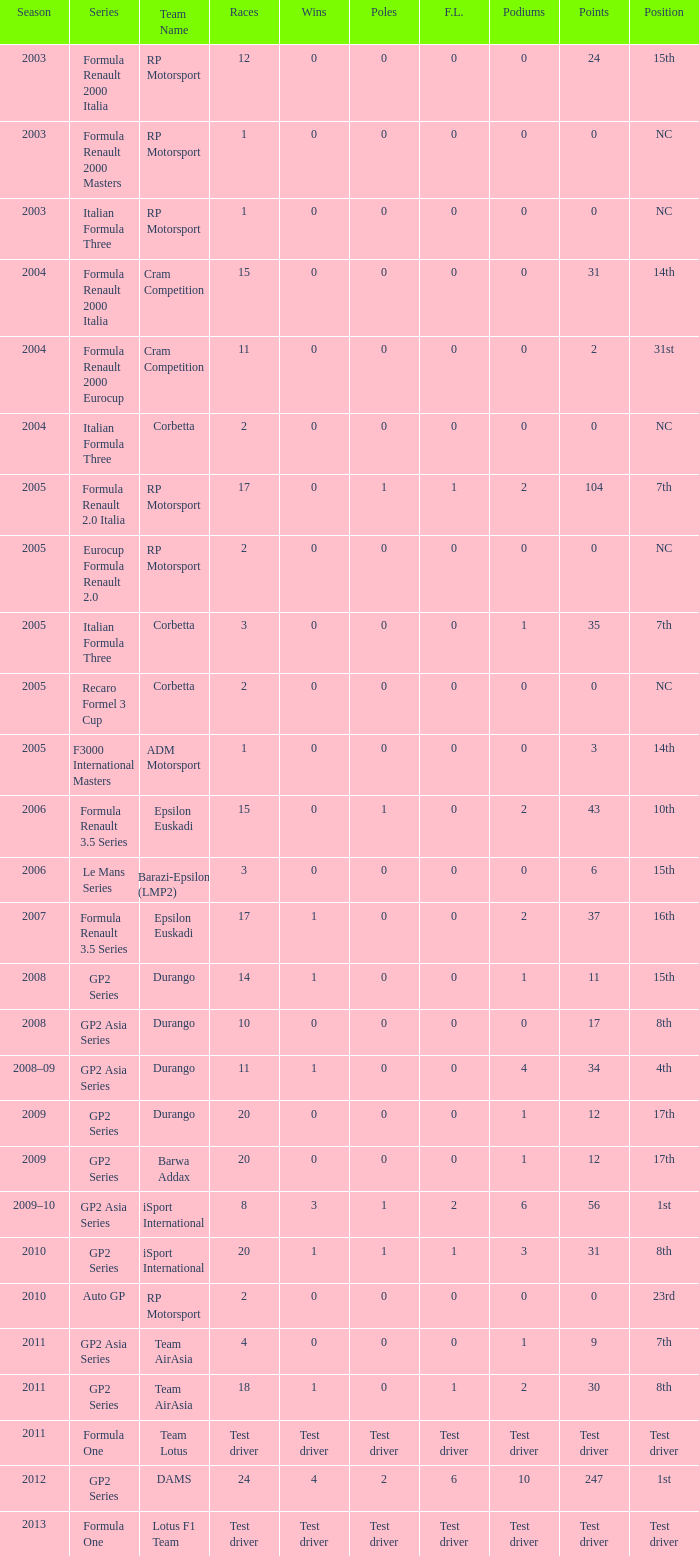What is the number of wins with a 0 F.L., 0 poles, a position of 7th, and 35 points? 0.0. Could you help me parse every detail presented in this table? {'header': ['Season', 'Series', 'Team Name', 'Races', 'Wins', 'Poles', 'F.L.', 'Podiums', 'Points', 'Position'], 'rows': [['2003', 'Formula Renault 2000 Italia', 'RP Motorsport', '12', '0', '0', '0', '0', '24', '15th'], ['2003', 'Formula Renault 2000 Masters', 'RP Motorsport', '1', '0', '0', '0', '0', '0', 'NC'], ['2003', 'Italian Formula Three', 'RP Motorsport', '1', '0', '0', '0', '0', '0', 'NC'], ['2004', 'Formula Renault 2000 Italia', 'Cram Competition', '15', '0', '0', '0', '0', '31', '14th'], ['2004', 'Formula Renault 2000 Eurocup', 'Cram Competition', '11', '0', '0', '0', '0', '2', '31st'], ['2004', 'Italian Formula Three', 'Corbetta', '2', '0', '0', '0', '0', '0', 'NC'], ['2005', 'Formula Renault 2.0 Italia', 'RP Motorsport', '17', '0', '1', '1', '2', '104', '7th'], ['2005', 'Eurocup Formula Renault 2.0', 'RP Motorsport', '2', '0', '0', '0', '0', '0', 'NC'], ['2005', 'Italian Formula Three', 'Corbetta', '3', '0', '0', '0', '1', '35', '7th'], ['2005', 'Recaro Formel 3 Cup', 'Corbetta', '2', '0', '0', '0', '0', '0', 'NC'], ['2005', 'F3000 International Masters', 'ADM Motorsport', '1', '0', '0', '0', '0', '3', '14th'], ['2006', 'Formula Renault 3.5 Series', 'Epsilon Euskadi', '15', '0', '1', '0', '2', '43', '10th'], ['2006', 'Le Mans Series', 'Barazi-Epsilon (LMP2)', '3', '0', '0', '0', '0', '6', '15th'], ['2007', 'Formula Renault 3.5 Series', 'Epsilon Euskadi', '17', '1', '0', '0', '2', '37', '16th'], ['2008', 'GP2 Series', 'Durango', '14', '1', '0', '0', '1', '11', '15th'], ['2008', 'GP2 Asia Series', 'Durango', '10', '0', '0', '0', '0', '17', '8th'], ['2008–09', 'GP2 Asia Series', 'Durango', '11', '1', '0', '0', '4', '34', '4th'], ['2009', 'GP2 Series', 'Durango', '20', '0', '0', '0', '1', '12', '17th'], ['2009', 'GP2 Series', 'Barwa Addax', '20', '0', '0', '0', '1', '12', '17th'], ['2009–10', 'GP2 Asia Series', 'iSport International', '8', '3', '1', '2', '6', '56', '1st'], ['2010', 'GP2 Series', 'iSport International', '20', '1', '1', '1', '3', '31', '8th'], ['2010', 'Auto GP', 'RP Motorsport', '2', '0', '0', '0', '0', '0', '23rd'], ['2011', 'GP2 Asia Series', 'Team AirAsia', '4', '0', '0', '0', '1', '9', '7th'], ['2011', 'GP2 Series', 'Team AirAsia', '18', '1', '0', '1', '2', '30', '8th'], ['2011', 'Formula One', 'Team Lotus', 'Test driver', 'Test driver', 'Test driver', 'Test driver', 'Test driver', 'Test driver', 'Test driver'], ['2012', 'GP2 Series', 'DAMS', '24', '4', '2', '6', '10', '247', '1st'], ['2013', 'Formula One', 'Lotus F1 Team', 'Test driver', 'Test driver', 'Test driver', 'Test driver', 'Test driver', 'Test driver', 'Test driver']]} 